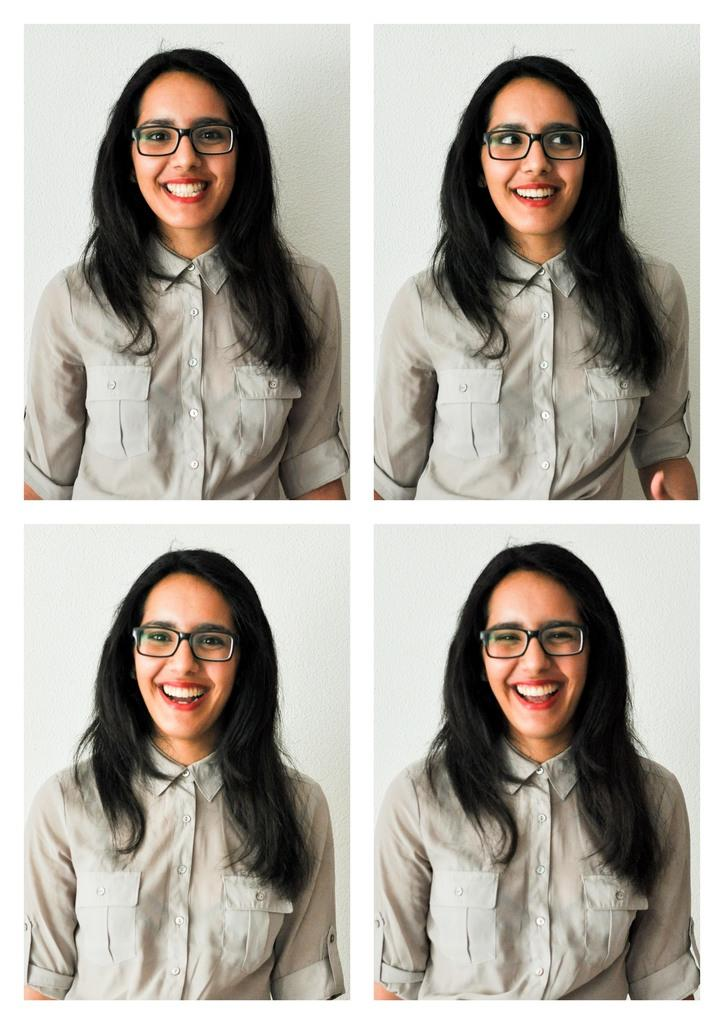What is the main subject of the image? The main subject of the image is a collage of a woman. What can be observed about the woman's appearance in the image? The woman is wearing spectacles. What is the woman's facial expression in the image? The woman is smiling. What type of rod can be seen in the woman's hand in the image? There is no rod present in the image; the woman is not holding anything. 